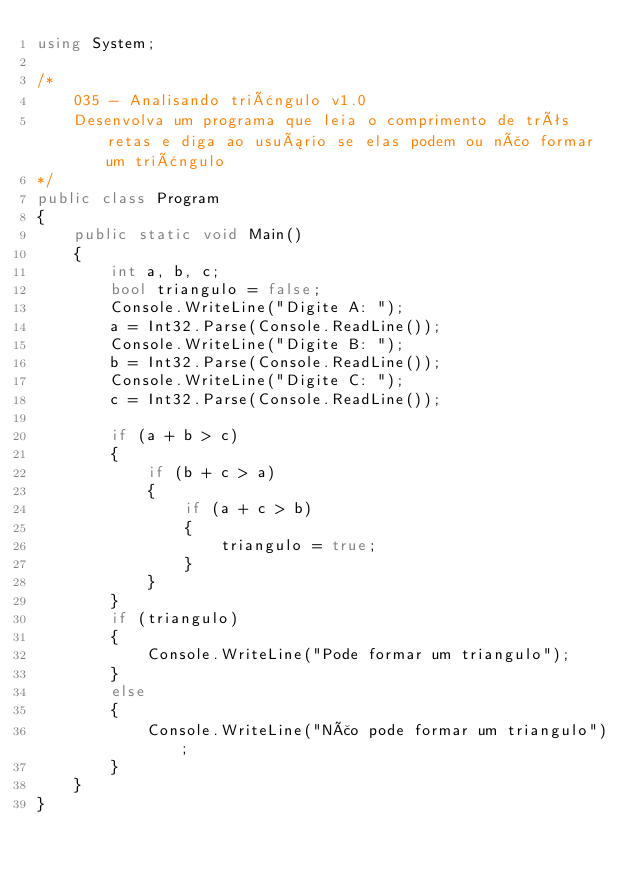Convert code to text. <code><loc_0><loc_0><loc_500><loc_500><_C#_>using System;

/*
	035 - Analisando triângulo v1.0
    Desenvolva um programa que leia o comprimento de três retas e diga ao usuário se elas podem ou não formar um triângulo
*/		
public class Program
{
	public static void Main()
	{
		int a, b, c;
		bool triangulo = false;
		Console.WriteLine("Digite A: ");
		a = Int32.Parse(Console.ReadLine());
		Console.WriteLine("Digite B: ");
		b = Int32.Parse(Console.ReadLine());
		Console.WriteLine("Digite C: ");
		c = Int32.Parse(Console.ReadLine());
		
		if (a + b > c)
		{
			if (b + c > a)
			{
				if (a + c > b)
				{
					triangulo = true;
				}
			}
		}
		if (triangulo)
		{
			Console.WriteLine("Pode formar um triangulo");
		}
		else
		{
			Console.WriteLine("Não pode formar um triangulo");
		}
	}
}</code> 